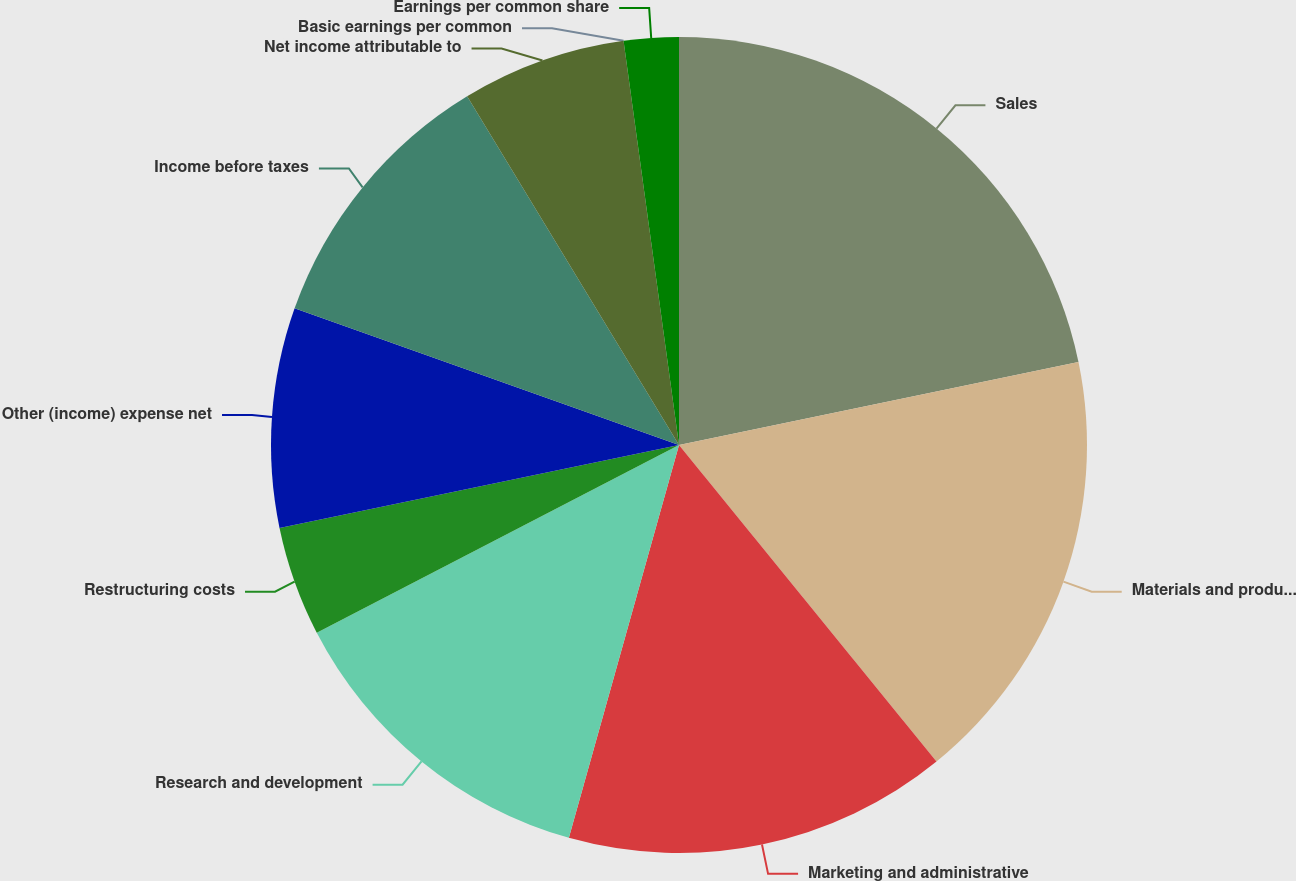Convert chart. <chart><loc_0><loc_0><loc_500><loc_500><pie_chart><fcel>Sales<fcel>Materials and production<fcel>Marketing and administrative<fcel>Research and development<fcel>Restructuring costs<fcel>Other (income) expense net<fcel>Income before taxes<fcel>Net income attributable to<fcel>Basic earnings per common<fcel>Earnings per common share<nl><fcel>21.74%<fcel>17.39%<fcel>15.22%<fcel>13.04%<fcel>4.35%<fcel>8.7%<fcel>10.87%<fcel>6.52%<fcel>0.0%<fcel>2.17%<nl></chart> 